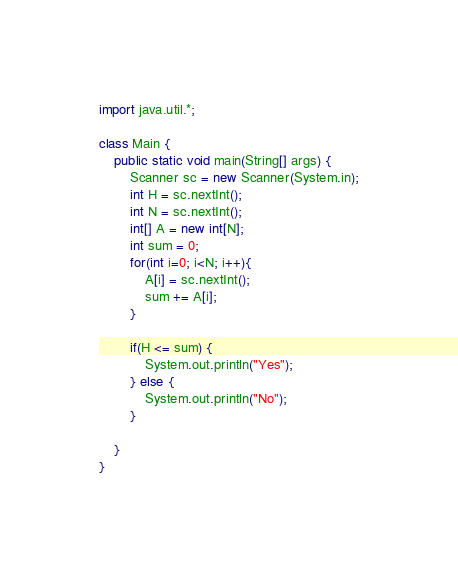<code> <loc_0><loc_0><loc_500><loc_500><_Java_>import java.util.*;

class Main {
    public static void main(String[] args) {
        Scanner sc = new Scanner(System.in);
        int H = sc.nextInt();
        int N = sc.nextInt();
        int[] A = new int[N];
        int sum = 0;
        for(int i=0; i<N; i++){
            A[i] = sc.nextInt();
            sum += A[i];
        }
        
        if(H <= sum) {
            System.out.println("Yes");
        } else {
            System.out.println("No");
        }

    }
}</code> 